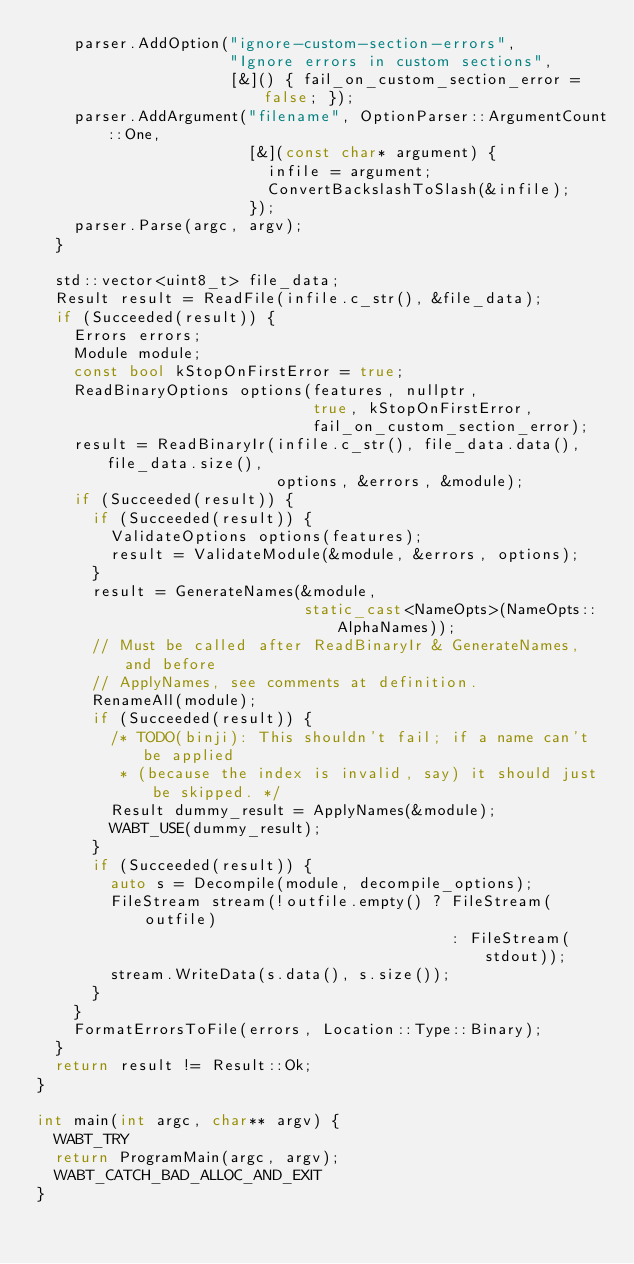<code> <loc_0><loc_0><loc_500><loc_500><_C++_>    parser.AddOption("ignore-custom-section-errors",
                     "Ignore errors in custom sections",
                     [&]() { fail_on_custom_section_error = false; });
    parser.AddArgument("filename", OptionParser::ArgumentCount::One,
                       [&](const char* argument) {
                         infile = argument;
                         ConvertBackslashToSlash(&infile);
                       });
    parser.Parse(argc, argv);
  }

  std::vector<uint8_t> file_data;
  Result result = ReadFile(infile.c_str(), &file_data);
  if (Succeeded(result)) {
    Errors errors;
    Module module;
    const bool kStopOnFirstError = true;
    ReadBinaryOptions options(features, nullptr,
                              true, kStopOnFirstError,
                              fail_on_custom_section_error);
    result = ReadBinaryIr(infile.c_str(), file_data.data(), file_data.size(),
                          options, &errors, &module);
    if (Succeeded(result)) {
      if (Succeeded(result)) {
        ValidateOptions options(features);
        result = ValidateModule(&module, &errors, options);
      }
      result = GenerateNames(&module,
                             static_cast<NameOpts>(NameOpts::AlphaNames));
      // Must be called after ReadBinaryIr & GenerateNames, and before
      // ApplyNames, see comments at definition.
      RenameAll(module);
      if (Succeeded(result)) {
        /* TODO(binji): This shouldn't fail; if a name can't be applied
         * (because the index is invalid, say) it should just be skipped. */
        Result dummy_result = ApplyNames(&module);
        WABT_USE(dummy_result);
      }
      if (Succeeded(result)) {
        auto s = Decompile(module, decompile_options);
        FileStream stream(!outfile.empty() ? FileStream(outfile)
                                             : FileStream(stdout));
        stream.WriteData(s.data(), s.size());
      }
    }
    FormatErrorsToFile(errors, Location::Type::Binary);
  }
  return result != Result::Ok;
}

int main(int argc, char** argv) {
  WABT_TRY
  return ProgramMain(argc, argv);
  WABT_CATCH_BAD_ALLOC_AND_EXIT
}
</code> 